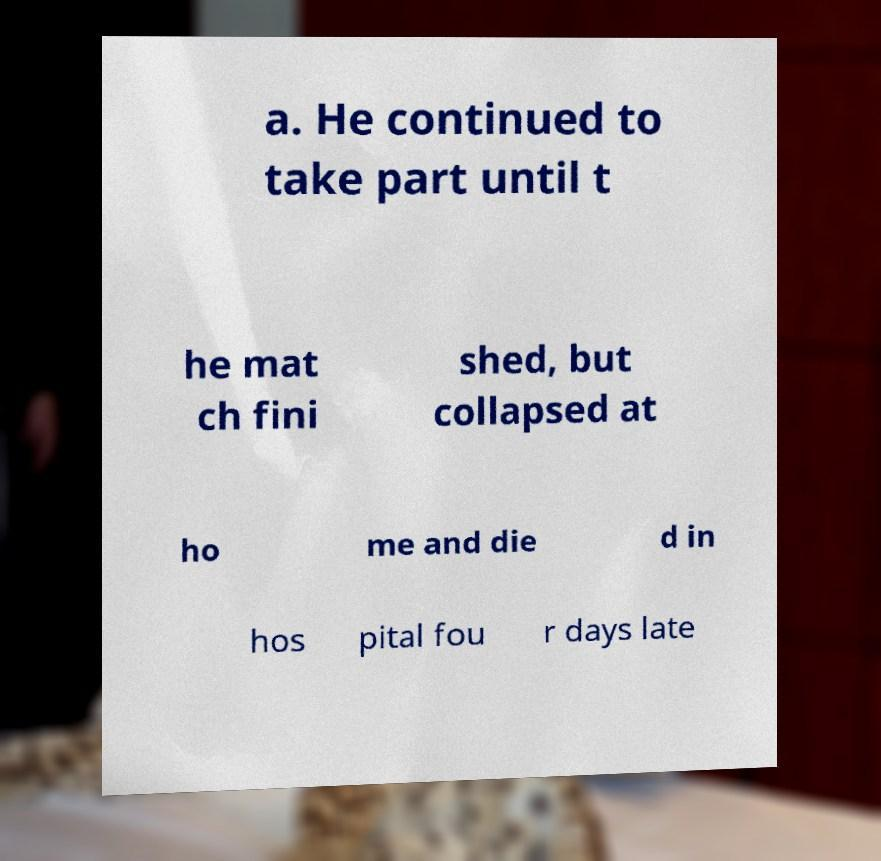Could you extract and type out the text from this image? a. He continued to take part until t he mat ch fini shed, but collapsed at ho me and die d in hos pital fou r days late 